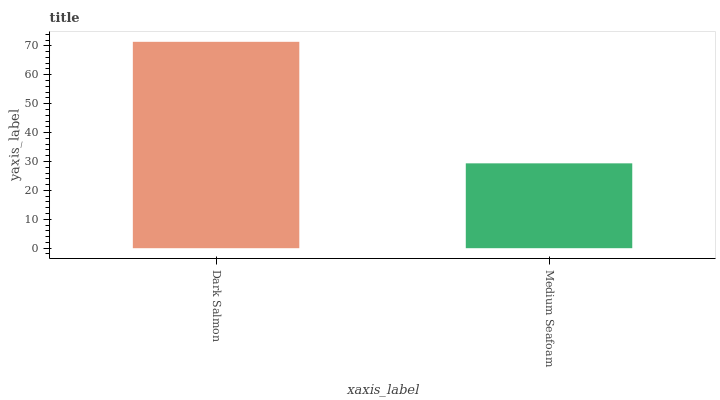Is Medium Seafoam the minimum?
Answer yes or no. Yes. Is Dark Salmon the maximum?
Answer yes or no. Yes. Is Medium Seafoam the maximum?
Answer yes or no. No. Is Dark Salmon greater than Medium Seafoam?
Answer yes or no. Yes. Is Medium Seafoam less than Dark Salmon?
Answer yes or no. Yes. Is Medium Seafoam greater than Dark Salmon?
Answer yes or no. No. Is Dark Salmon less than Medium Seafoam?
Answer yes or no. No. Is Dark Salmon the high median?
Answer yes or no. Yes. Is Medium Seafoam the low median?
Answer yes or no. Yes. Is Medium Seafoam the high median?
Answer yes or no. No. Is Dark Salmon the low median?
Answer yes or no. No. 